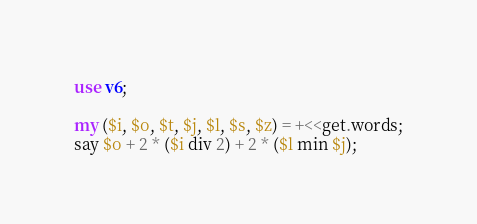<code> <loc_0><loc_0><loc_500><loc_500><_Perl_>use v6;

my ($i, $o, $t, $j, $l, $s, $z) = +<<get.words;
say $o + 2 * ($i div 2) + 2 * ($l min $j);
</code> 